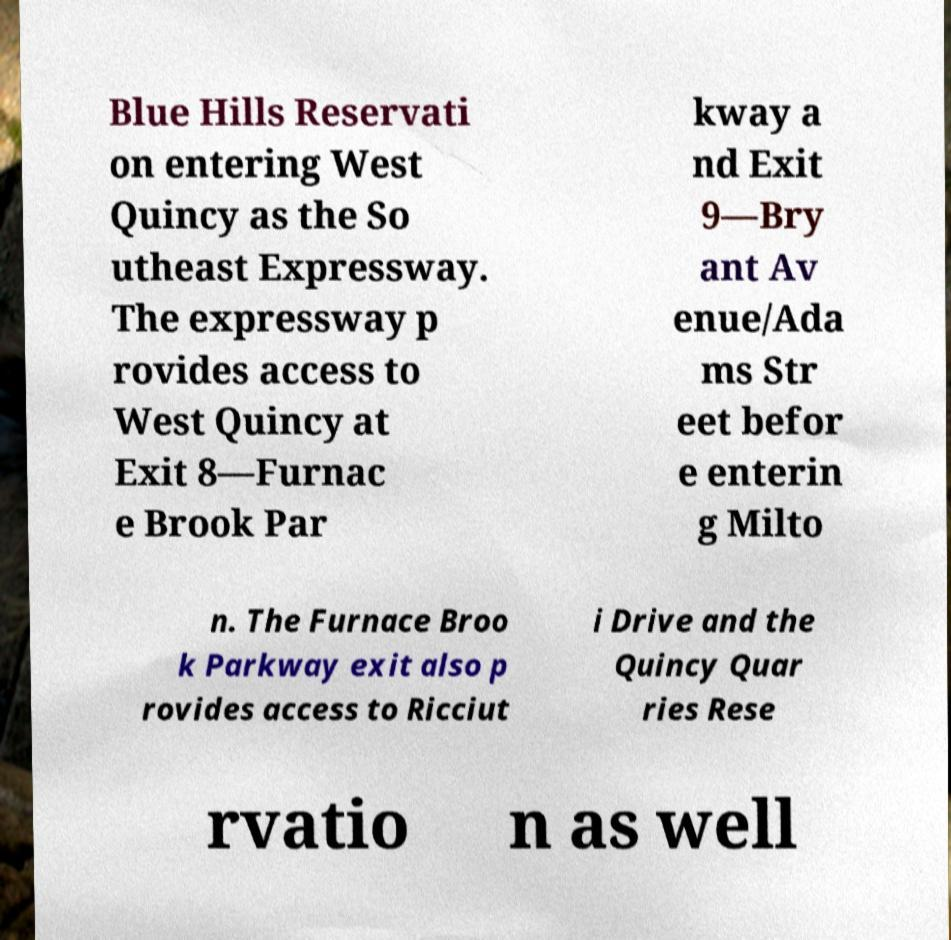Can you accurately transcribe the text from the provided image for me? Blue Hills Reservati on entering West Quincy as the So utheast Expressway. The expressway p rovides access to West Quincy at Exit 8—Furnac e Brook Par kway a nd Exit 9—Bry ant Av enue/Ada ms Str eet befor e enterin g Milto n. The Furnace Broo k Parkway exit also p rovides access to Ricciut i Drive and the Quincy Quar ries Rese rvatio n as well 